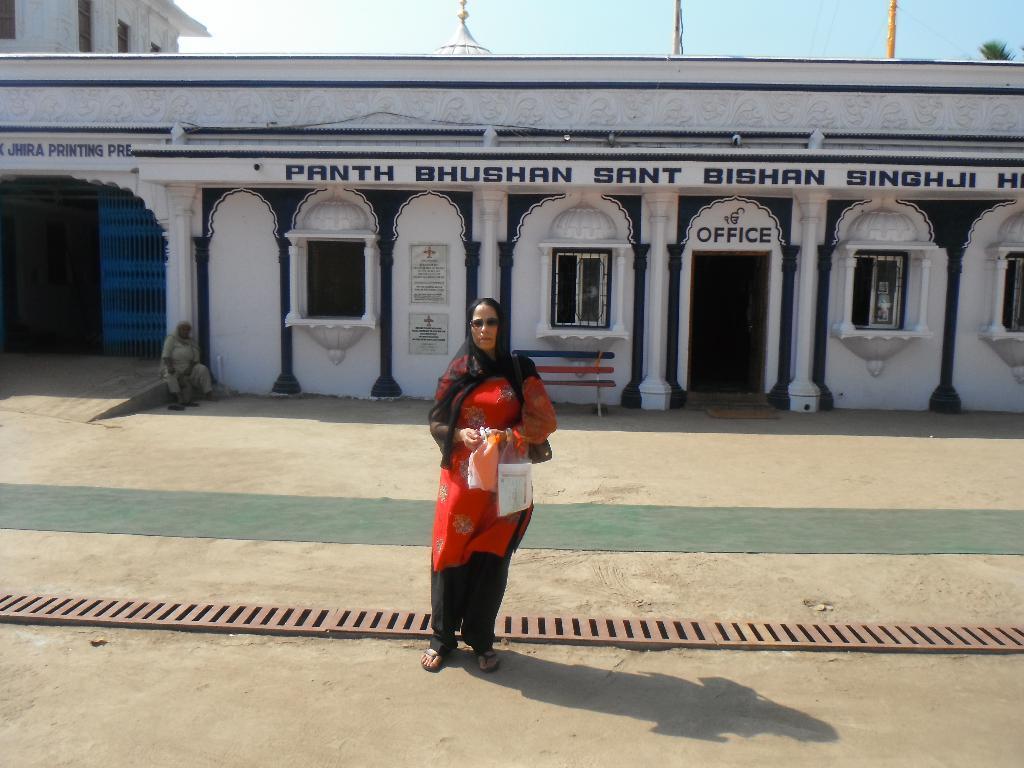How would you summarize this image in a sentence or two? In this image there is one person standing in the middle of this image and holding some covers. There is a building in the background. There is one person sitting on the left side of this image. there is a sky on the top of this image. There is a ground in the bottom of this image. 